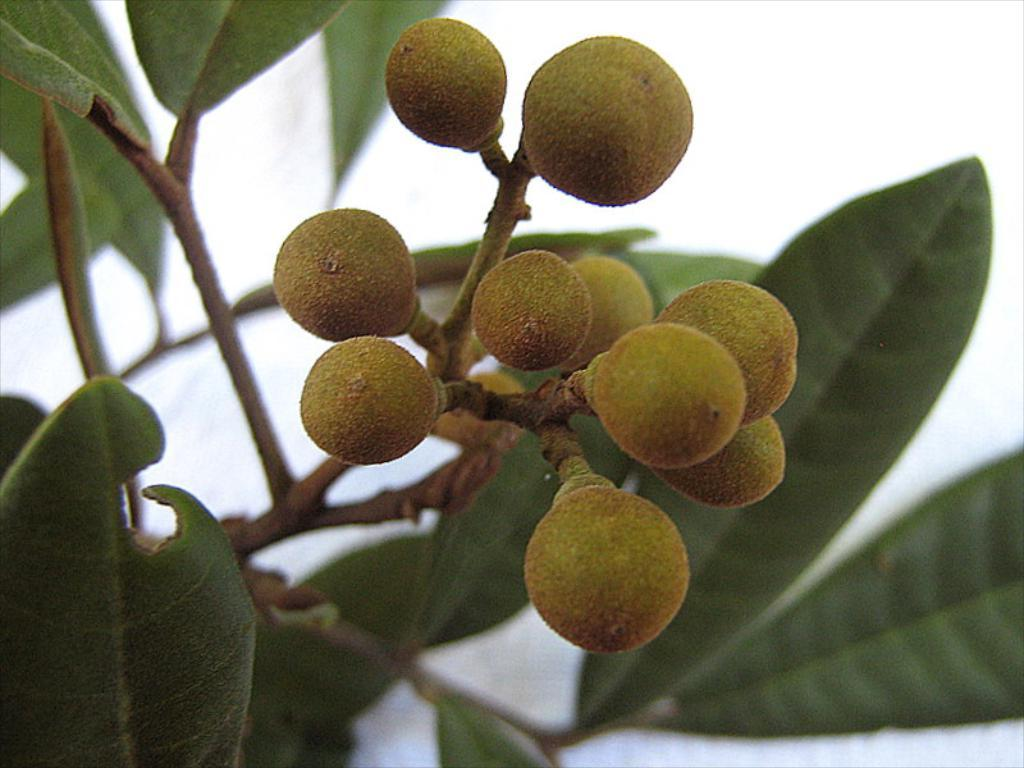What is the main subject of the image? The main subject of the image is a fruit on a plant. Where is the fruit located in the image? The fruit is in the center of the image. What is the condition of the sky in the image? The sky is cloudy in the image. What route does the grandmother take to visit the fruit in the image? There is no grandmother present in the image, and therefore no route can be determined. 